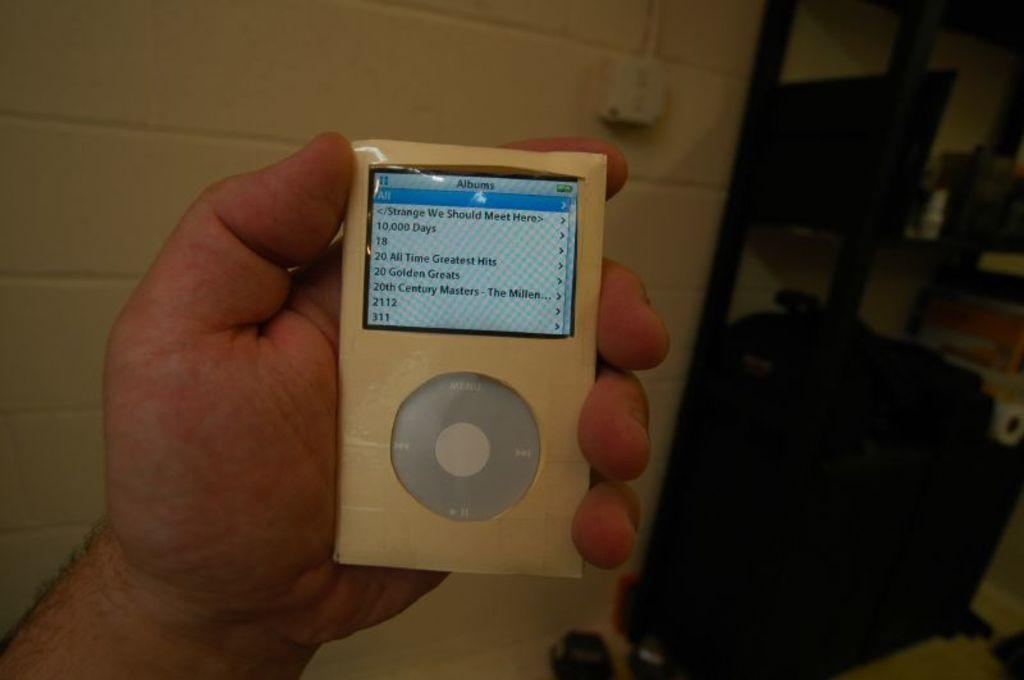What is being held in the hand in the image? There is a gadget held in a hand in the image. What can be seen on the wall in the background? There is a switch board on a wall in the background. What is visible in the background besides the switch board? There is a bag visible in the background, as well as additional unspecified things. What type of line is being operated in the image? There is no line being operated in the image; it features a gadget held in a hand, a switch board on a wall, a bag, and additional unspecified things in the background. 